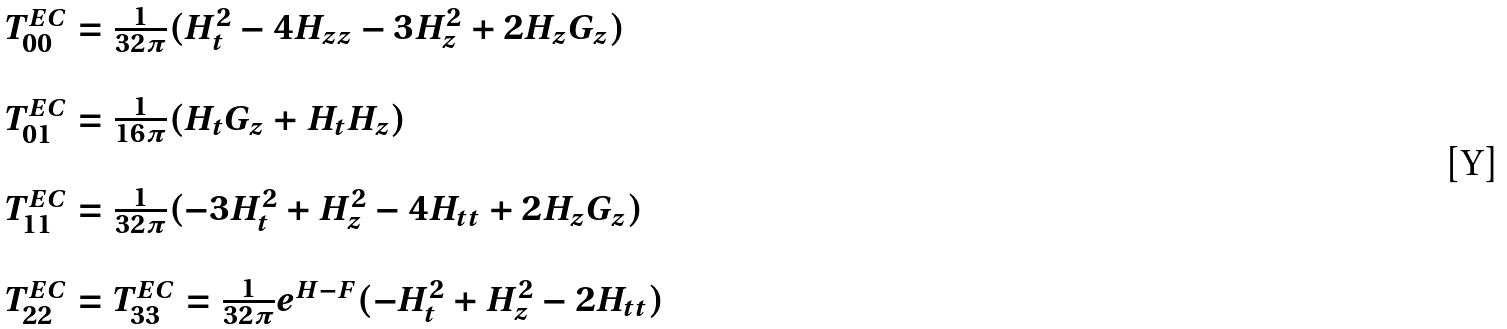<formula> <loc_0><loc_0><loc_500><loc_500>\begin{array} { l l l l } T ^ { E C } _ { 0 0 } = { \frac { 1 } { 3 2 { \pi } } } ( H ^ { 2 } _ { t } - 4 H _ { z z } - 3 H ^ { 2 } _ { z } + 2 H _ { z } G _ { z } ) \\ \\ T ^ { E C } _ { 0 1 } = { \frac { 1 } { 1 6 { \pi } } } ( H _ { t } G _ { z } + H _ { t } H _ { z } ) \\ \\ T ^ { E C } _ { 1 1 } = \frac { 1 } { 3 2 { \pi } } ( - 3 H ^ { 2 } _ { t } + H ^ { 2 } _ { z } - 4 H _ { t t } + 2 H _ { z } G _ { z } ) \\ \\ T ^ { E C } _ { 2 2 } = T ^ { E C } _ { 3 3 } = \frac { 1 } { 3 2 { \pi } } e ^ { H - F } ( - H ^ { 2 } _ { t } + H ^ { 2 } _ { z } - 2 H _ { t t } ) \\ \end{array}</formula> 